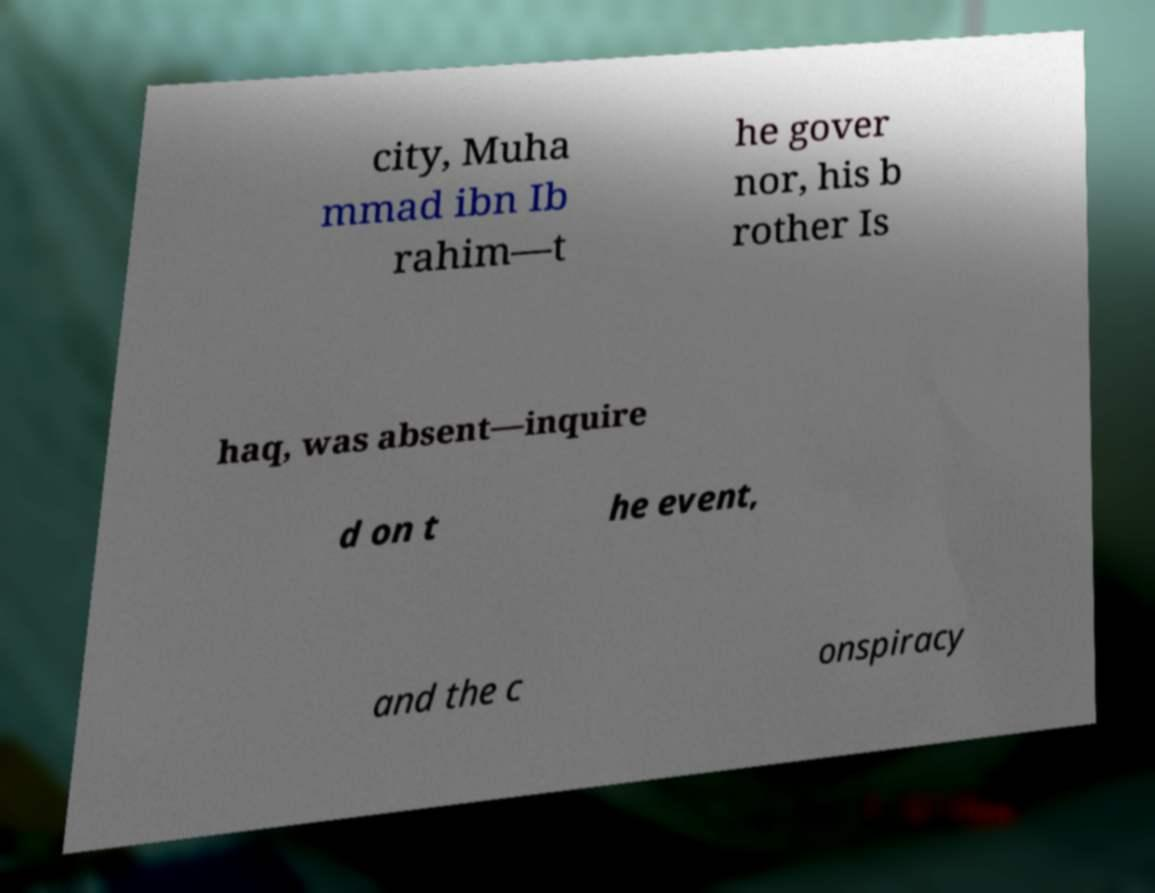Could you assist in decoding the text presented in this image and type it out clearly? city, Muha mmad ibn Ib rahim—t he gover nor, his b rother Is haq, was absent—inquire d on t he event, and the c onspiracy 